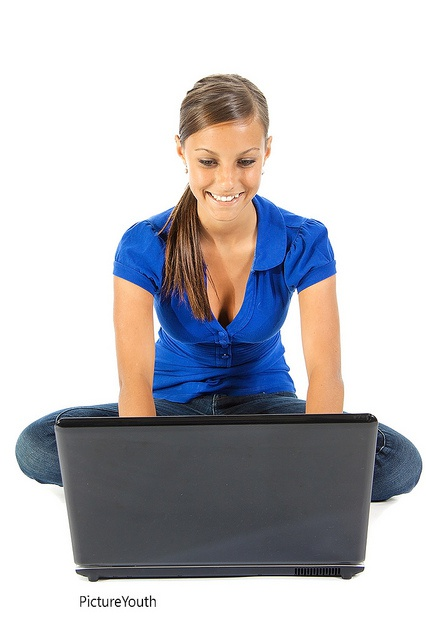Describe the objects in this image and their specific colors. I can see people in white, tan, blue, and black tones and laptop in white, gray, and black tones in this image. 